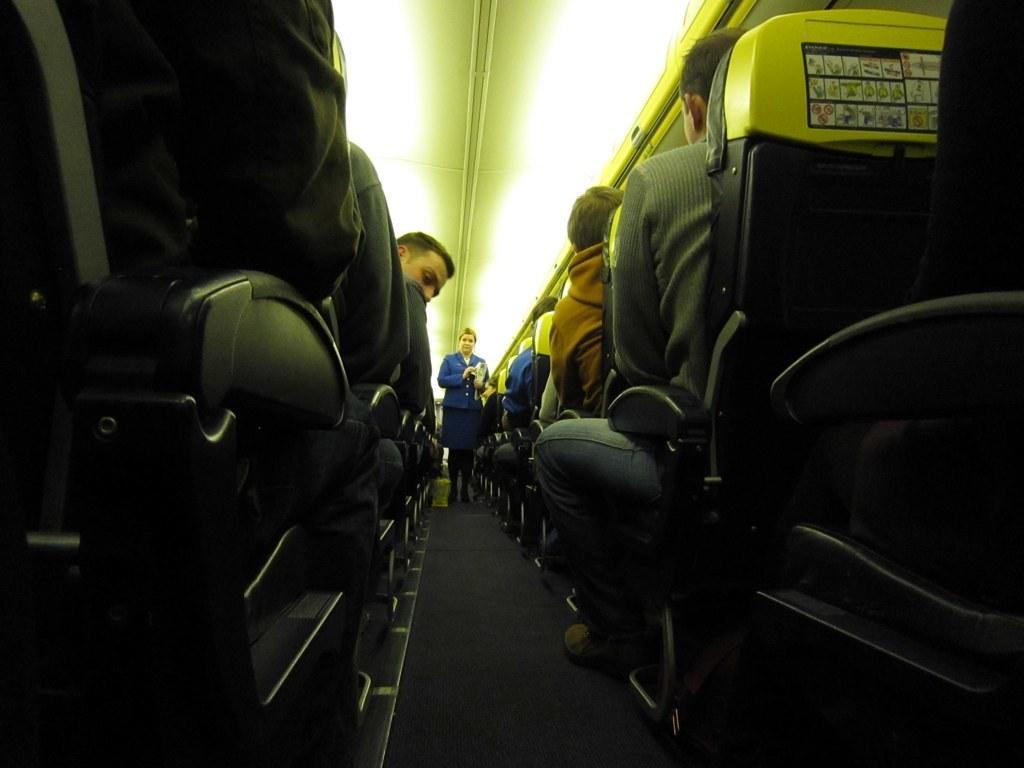In one or two sentences, can you explain what this image depicts? In this image on the left and right side, I can see some people are sitting on the chairs. In the middle I can see a woman standing. 